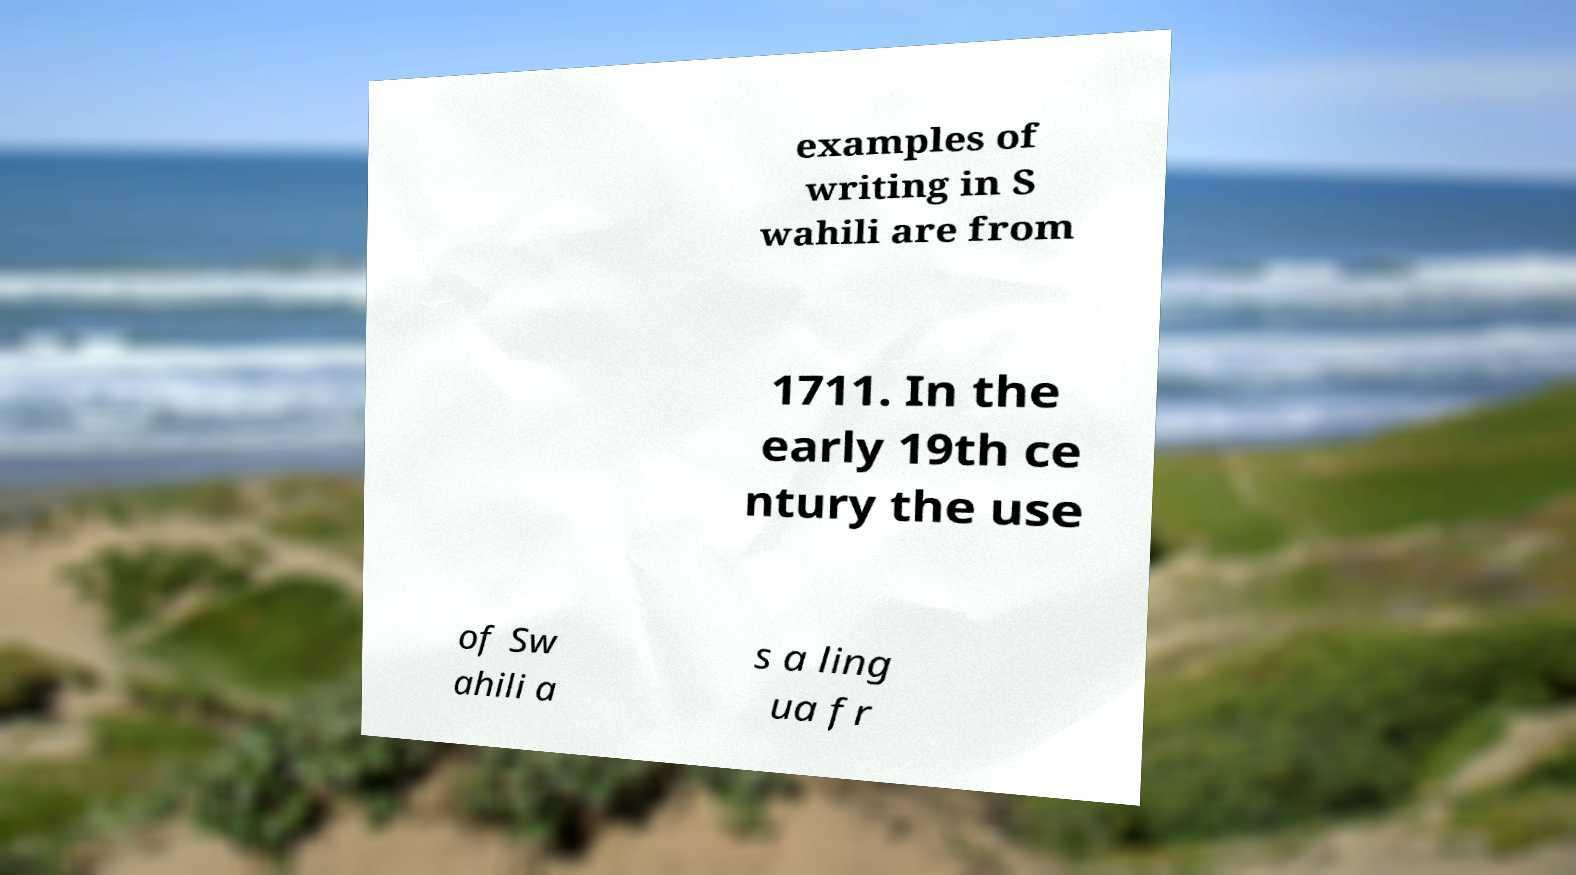There's text embedded in this image that I need extracted. Can you transcribe it verbatim? examples of writing in S wahili are from 1711. In the early 19th ce ntury the use of Sw ahili a s a ling ua fr 